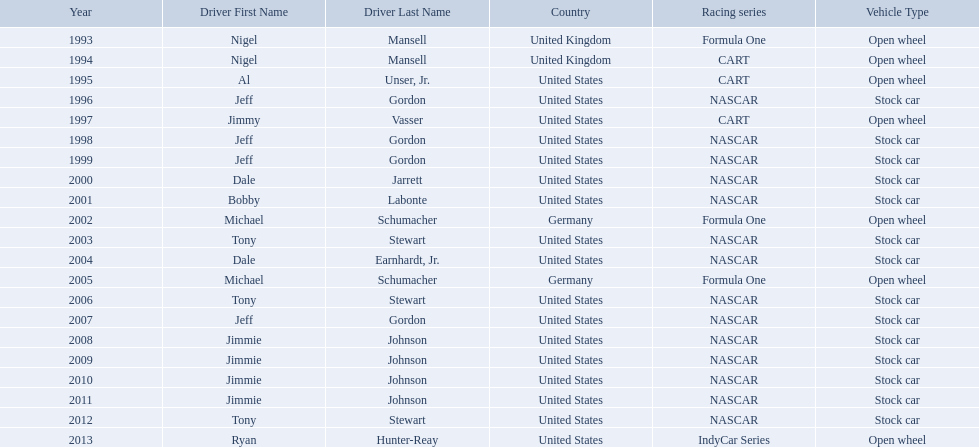Who won an espy in the year 2004, bobby labonte, tony stewart, dale earnhardt jr., or jeff gordon? Dale Earnhardt, Jr. Who won the espy in the year 1997; nigel mansell, al unser, jr., jeff gordon, or jimmy vasser? Jimmy Vasser. Which one only has one espy; nigel mansell, al unser jr., michael schumacher, or jeff gordon? Al Unser, Jr. 